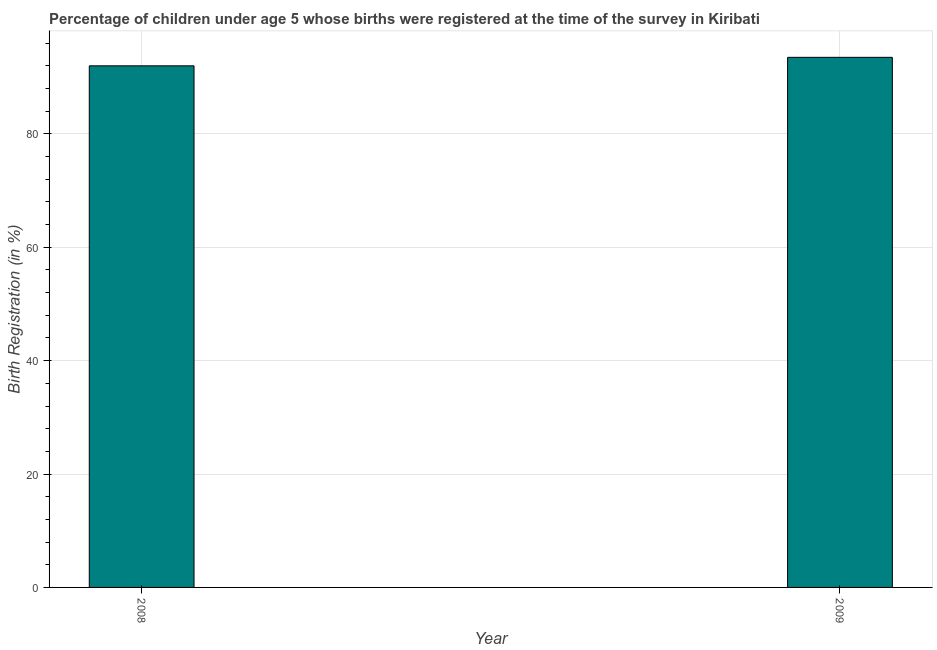Does the graph contain grids?
Keep it short and to the point. Yes. What is the title of the graph?
Provide a short and direct response. Percentage of children under age 5 whose births were registered at the time of the survey in Kiribati. What is the label or title of the Y-axis?
Give a very brief answer. Birth Registration (in %). What is the birth registration in 2008?
Give a very brief answer. 92. Across all years, what is the maximum birth registration?
Keep it short and to the point. 93.5. Across all years, what is the minimum birth registration?
Provide a succinct answer. 92. What is the sum of the birth registration?
Your response must be concise. 185.5. What is the average birth registration per year?
Offer a very short reply. 92.75. What is the median birth registration?
Offer a terse response. 92.75. What is the ratio of the birth registration in 2008 to that in 2009?
Give a very brief answer. 0.98. Is the birth registration in 2008 less than that in 2009?
Provide a succinct answer. Yes. How many bars are there?
Give a very brief answer. 2. How many years are there in the graph?
Ensure brevity in your answer.  2. What is the Birth Registration (in %) of 2008?
Offer a terse response. 92. What is the Birth Registration (in %) in 2009?
Your response must be concise. 93.5. 